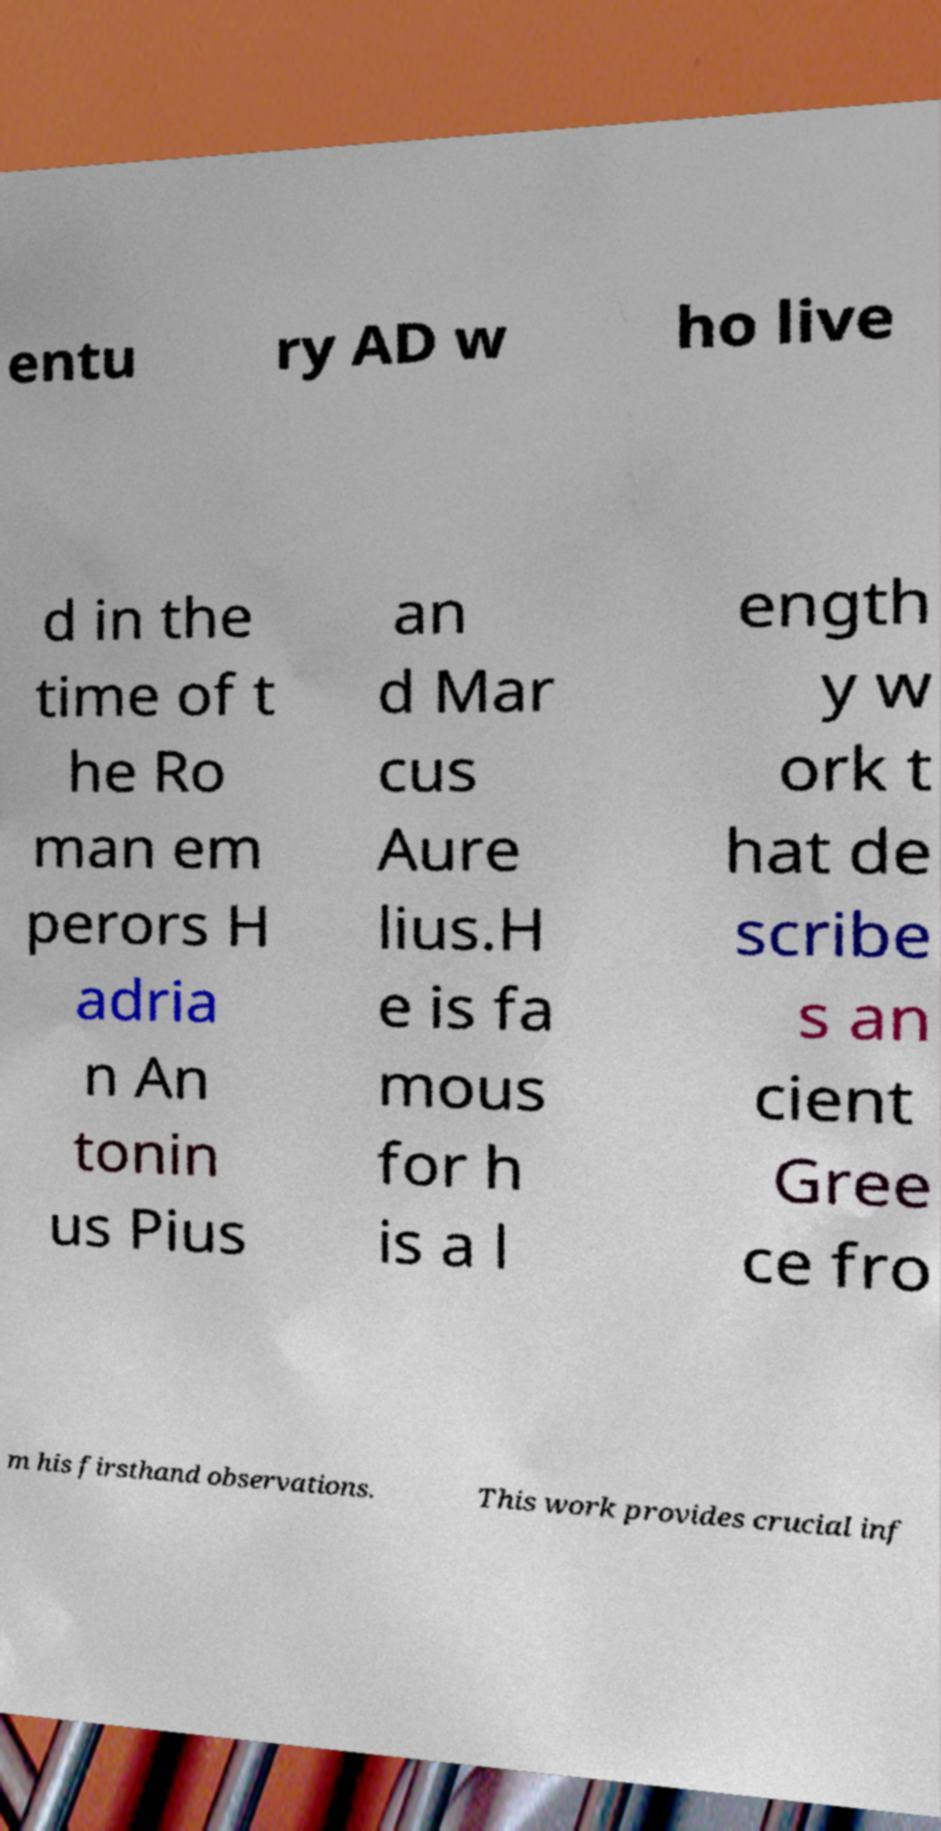Can you read and provide the text displayed in the image?This photo seems to have some interesting text. Can you extract and type it out for me? entu ry AD w ho live d in the time of t he Ro man em perors H adria n An tonin us Pius an d Mar cus Aure lius.H e is fa mous for h is a l ength y w ork t hat de scribe s an cient Gree ce fro m his firsthand observations. This work provides crucial inf 